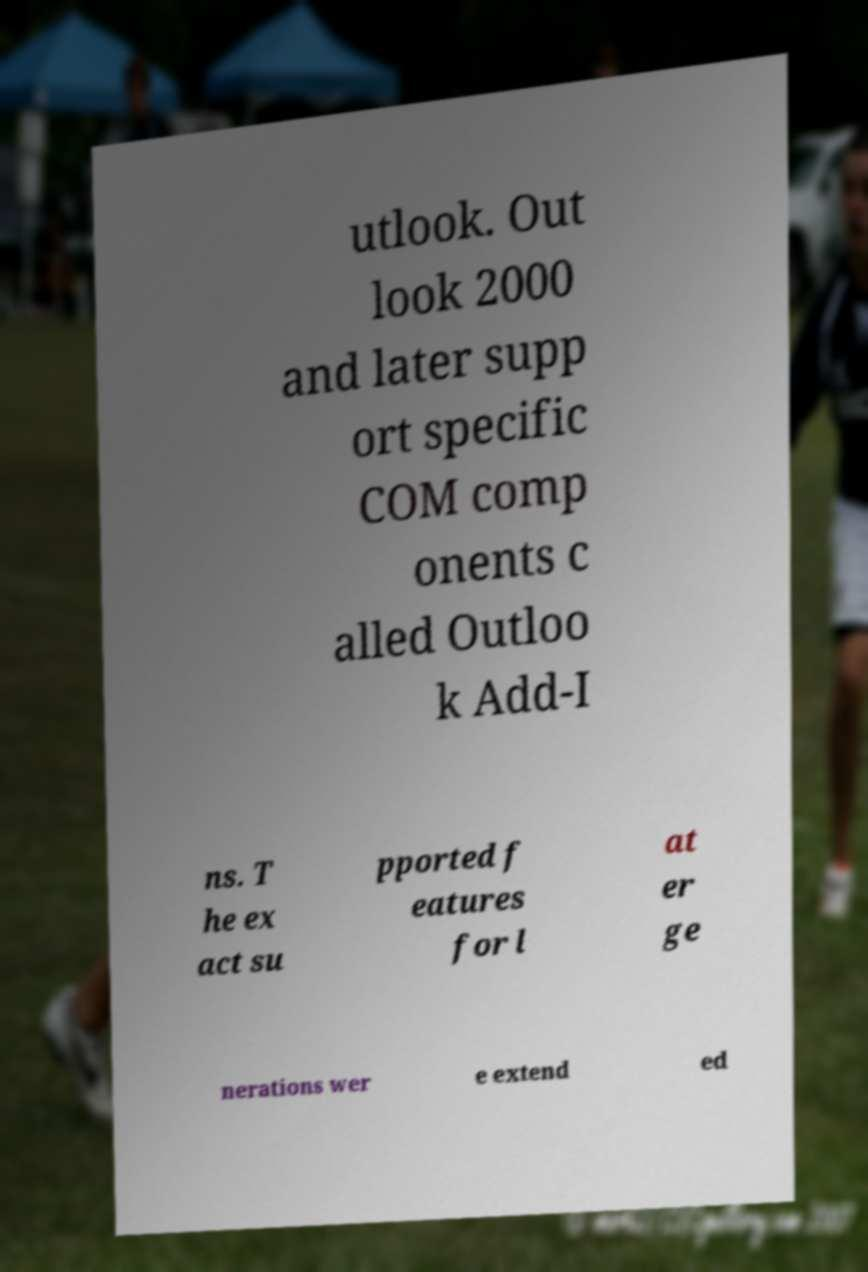There's text embedded in this image that I need extracted. Can you transcribe it verbatim? utlook. Out look 2000 and later supp ort specific COM comp onents c alled Outloo k Add-I ns. T he ex act su pported f eatures for l at er ge nerations wer e extend ed 